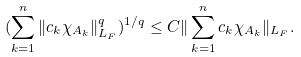<formula> <loc_0><loc_0><loc_500><loc_500>( \sum _ { k = 1 } ^ { n } \| c _ { k } \chi _ { A _ { k } } \| _ { L _ { F } } ^ { q } ) ^ { 1 / q } \leq C \| \sum _ { k = 1 } ^ { n } c _ { k } \chi _ { A _ { k } } \| _ { L _ { F } } .</formula> 